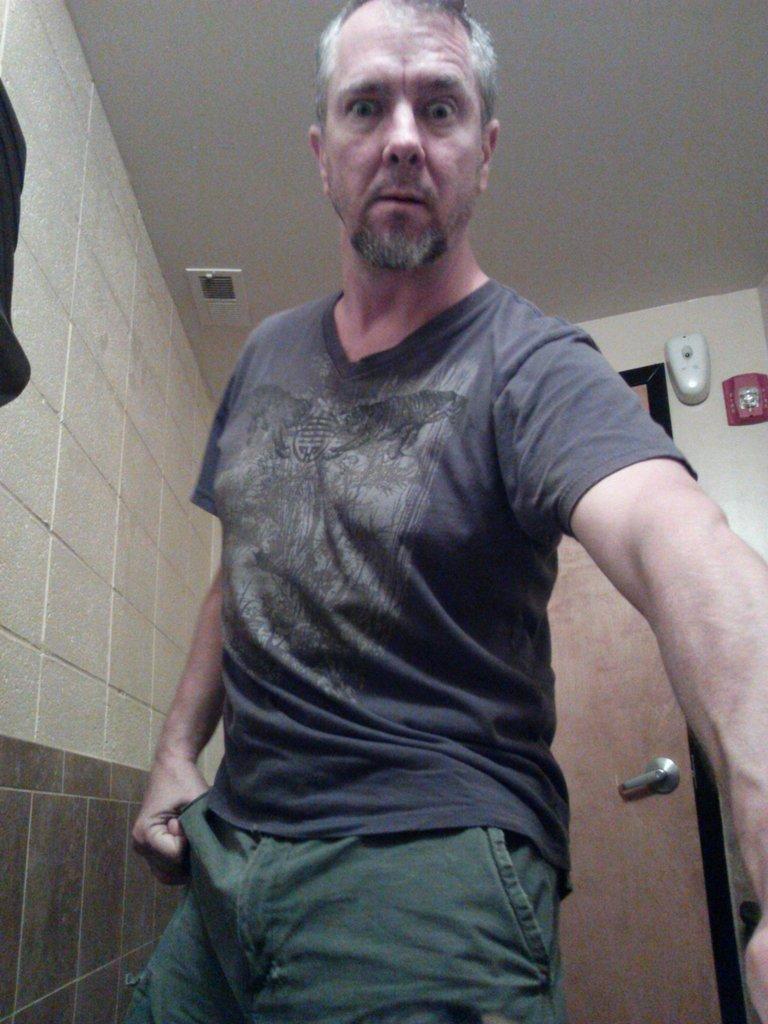Describe this image in one or two sentences. In this image, there is a person wearing clothes and standing in front of the door. There is a wall on the left side of the image. 